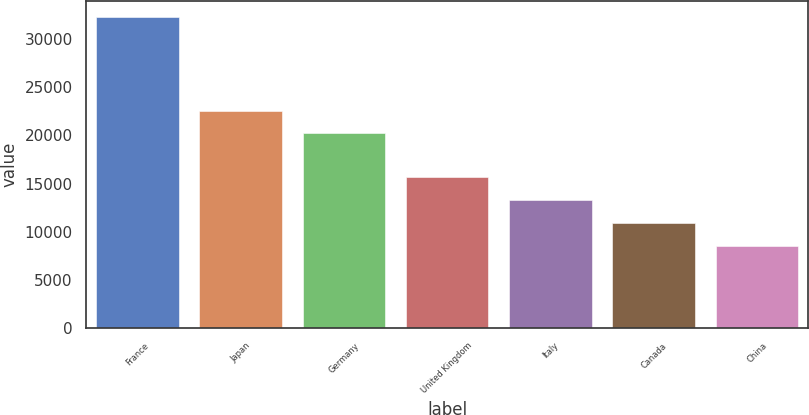Convert chart to OTSL. <chart><loc_0><loc_0><loc_500><loc_500><bar_chart><fcel>France<fcel>Japan<fcel>Germany<fcel>United Kingdom<fcel>Italy<fcel>Canada<fcel>China<nl><fcel>32354<fcel>22589.2<fcel>20205<fcel>15664.6<fcel>13280.4<fcel>10896.2<fcel>8512<nl></chart> 